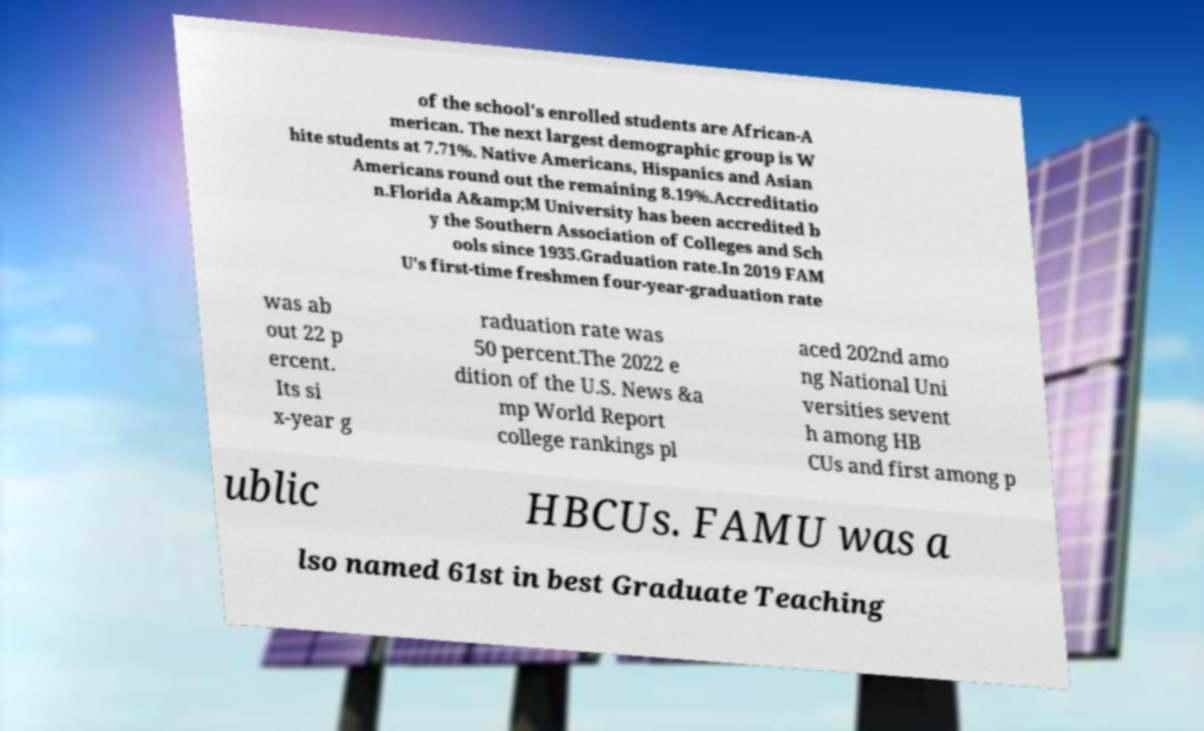What messages or text are displayed in this image? I need them in a readable, typed format. of the school's enrolled students are African-A merican. The next largest demographic group is W hite students at 7.71%. Native Americans, Hispanics and Asian Americans round out the remaining 8.19%.Accreditatio n.Florida A&amp;M University has been accredited b y the Southern Association of Colleges and Sch ools since 1935.Graduation rate.In 2019 FAM U's first-time freshmen four-year-graduation rate was ab out 22 p ercent. Its si x-year g raduation rate was 50 percent.The 2022 e dition of the U.S. News &a mp World Report college rankings pl aced 202nd amo ng National Uni versities sevent h among HB CUs and first among p ublic HBCUs. FAMU was a lso named 61st in best Graduate Teaching 